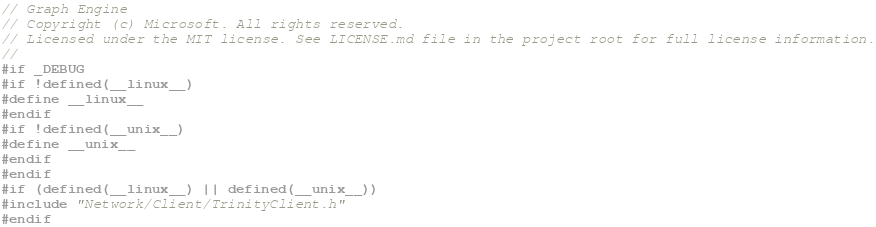Convert code to text. <code><loc_0><loc_0><loc_500><loc_500><_C_>// Graph Engine
// Copyright (c) Microsoft. All rights reserved.
// Licensed under the MIT license. See LICENSE.md file in the project root for full license information.
//
#if _DEBUG
#if !defined(__linux__)
#define __linux__
#endif
#if !defined(__unix__)
#define __unix__
#endif
#endif
#if (defined(__linux__) || defined(__unix__))
#include "Network/Client/TrinityClient.h"
#endif
</code> 